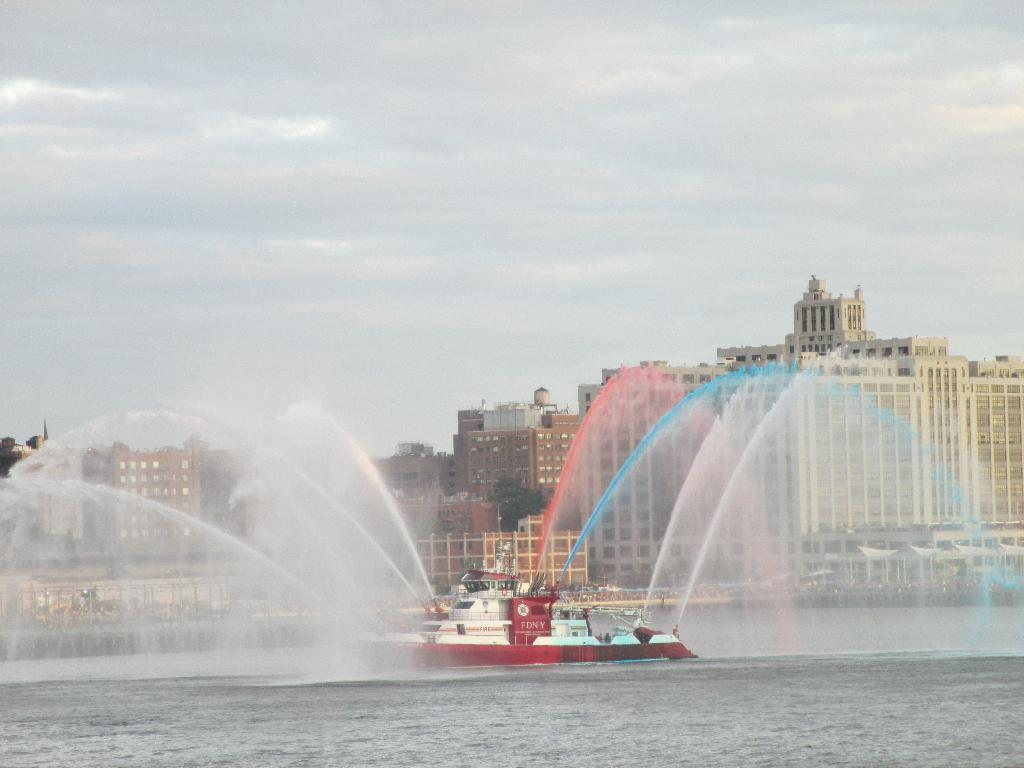What is the main subject in the center of the image? There is a ship in the water in the center of the image. What can be seen in the background of the image? There are buildings and the sky visible in the background of the image. What direction is the crow flying in the image? There is no crow present in the image. What part of the body is visible on the ship in the image? There is no body visible on the ship in the image; it is a vessel in the water. 